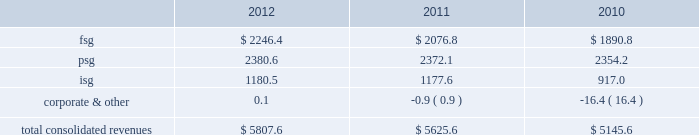Strategy our mission is to achieve sustainable revenue and earnings growth through providing superior solutions to our customers .
Our strategy to achieve this has been and will continue to be built on the following pillars : 2022 expand client relationships 2014 the overall market we serve continues to gravitate beyond single-product purchases to multi-solution partnerships .
As the market dynamics shift , we expect our clients to rely more on our multidimensional service offerings .
Our leveraged solutions and processing expertise can drive meaningful value and cost savings to our clients through more efficient operating processes , improved service quality and speed for our clients' customers .
2022 buy , build or partner to add solutions to cross-sell 2014 we continue to invest in growth through internal product development , as well as through product-focused or market-centric acquisitions that complement and extend our existing capabilities and provide us with additional solutions to cross-sell .
We also partner from time to time with other entities to provide comprehensive offerings to our customers .
By investing in solution innovation and integration , we continue to expand our value proposition to clients .
2022 support our clients through market transformation 2014 the changing market dynamics are transforming the way our clients operate , which is driving incremental demand for our leveraged solutions , consulting expertise , and services around intellectual property .
Our depth of services capabilities enables us to become involved earlier in the planning and design process to assist our clients as they manage through these changes .
2022 continually improve to drive margin expansion 2014 we strive to optimize our performance through investments in infrastructure enhancements and other measures that are designed to drive organic revenue growth and margin expansion .
2022 build global diversification 2014 we continue to deploy resources in emerging global markets where we expect to achieve meaningful scale .
Revenues by segment the table below summarizes the revenues by our reporting segments ( in millions ) : .
Financial solutions group the focus of fsg is to provide the most comprehensive software and services for the core processing , customer channel , treasury services , cash management , wealth management and capital market operations of our financial institution customers in north america .
We service the core and related ancillary processing needs of north american banks , credit unions , automotive financial companies , commercial lenders , and independent community and savings institutions .
Fis offers a broad selection of in-house and outsourced solutions to banking customers that span the range of asset sizes .
Fsg customers are typically committed under multi-year contracts that provide a stable , recurring revenue base and opportunities for cross-selling additional financial and payments offerings .
We employ several business models to provide our solutions to our customers .
We typically deliver the highest value to our customers when we combine our software applications and deliver them in one of several types of outsourcing arrangements , such as an application service provider , facilities management processing or an application management arrangement .
We are also able to deliver individual applications through a software licensing arrangement .
Based upon our expertise gained through the foregoing arrangements , some clients also retain us to manage their it operations without using any of our proprietary software .
Our solutions in this segment include: .
What portion of the total consolidated revenues is generated from fsg segment in 2018? 
Computations: (2246.4 / 5807.6)
Answer: 0.3868. 